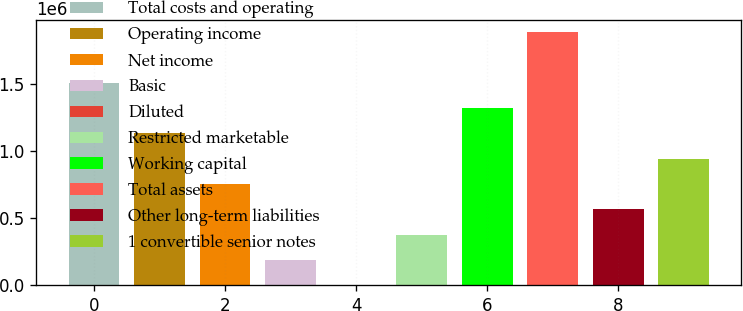Convert chart. <chart><loc_0><loc_0><loc_500><loc_500><bar_chart><fcel>Total costs and operating<fcel>Operating income<fcel>Net income<fcel>Basic<fcel>Diluted<fcel>Restricted marketable<fcel>Working capital<fcel>Total assets<fcel>Other long-term liabilities<fcel>1 convertible senior notes<nl><fcel>1.50476e+06<fcel>1.12857e+06<fcel>752381<fcel>188096<fcel>0.79<fcel>376191<fcel>1.31667e+06<fcel>1.88095e+06<fcel>564286<fcel>940476<nl></chart> 